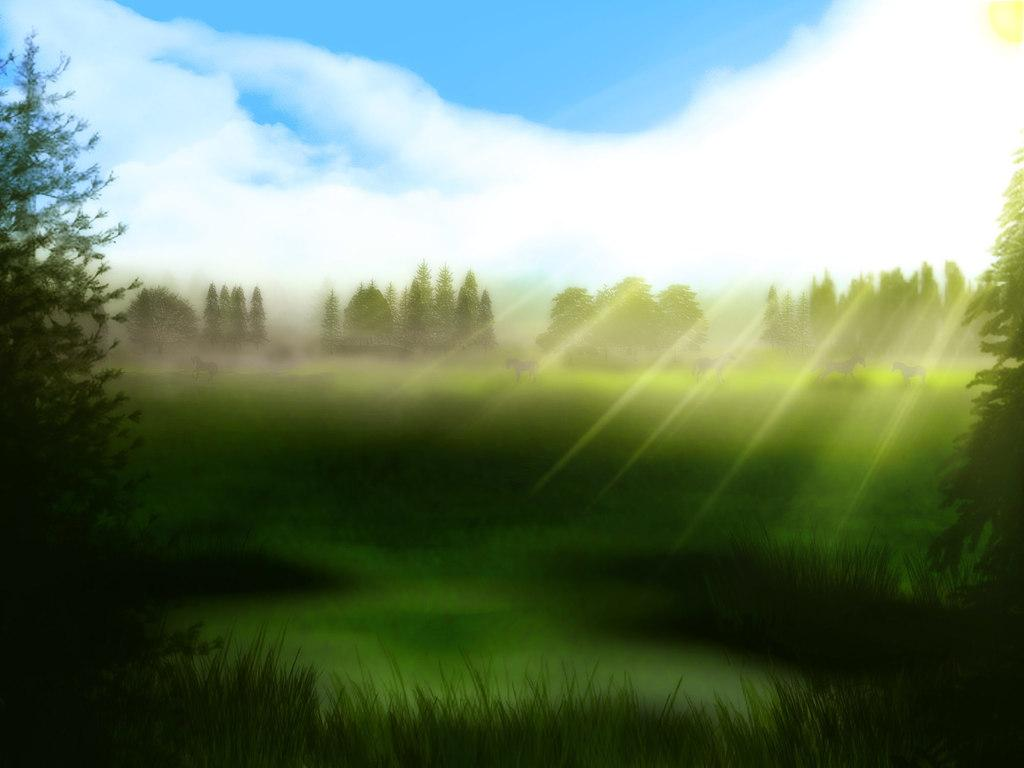What type of terrain is visible in the image? There is land with grass in the image. What can be seen surrounding the land? Trees are present around the land. Are there any living creatures on the land? Yes, there are animals on the land. What is the color of the sky in the image? The sky is blue in the image. What else can be seen in the sky? Clouds are visible in the sky. What advice is the bucket giving to the animals in the image? There is no bucket present in the image, and therefore no advice can be given. 